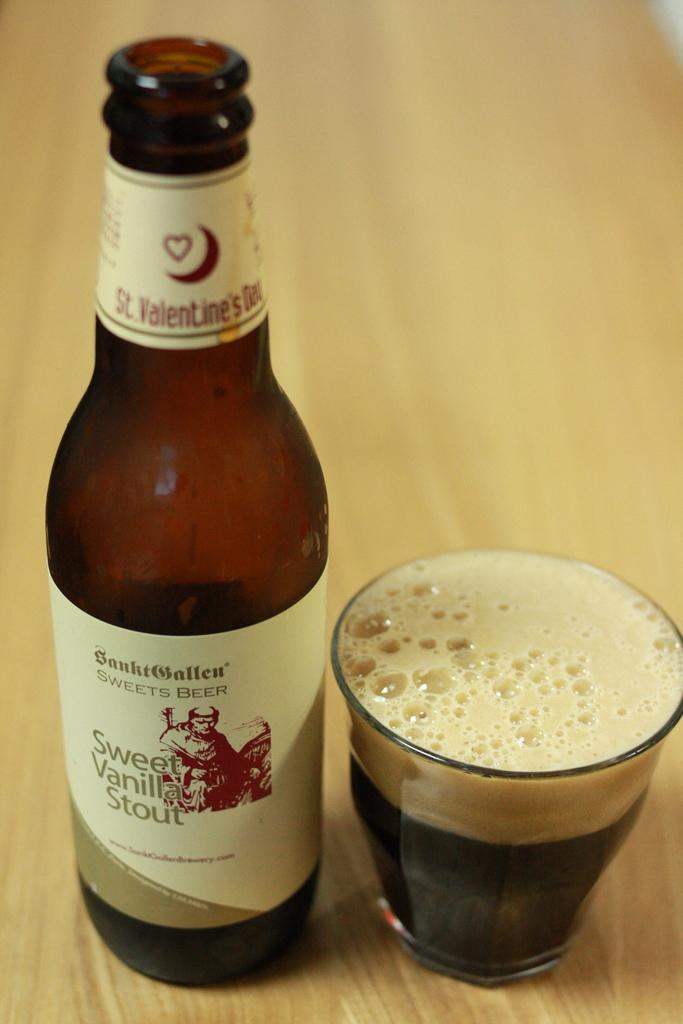Provide a one-sentence caption for the provided image. A Sweet Vanilla Stout beer sits on a wooden table alongside a glass filled with very dark beer to the brim with foam on top. 